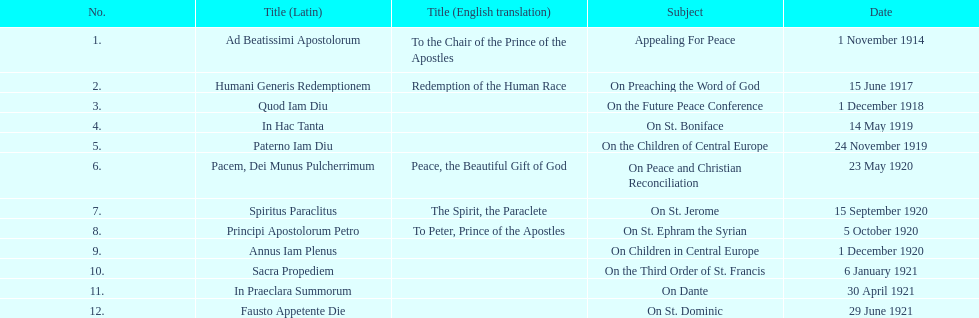In how many encyclopedias can one find subjects that pertain particularly to children? 2. 